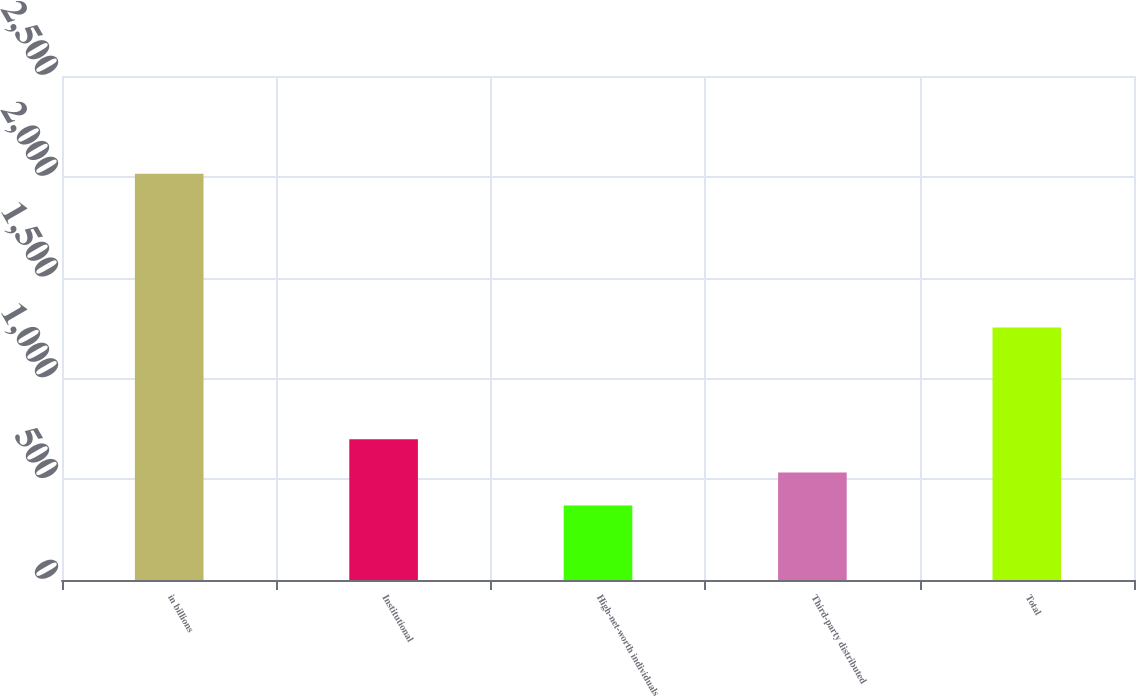Convert chart to OTSL. <chart><loc_0><loc_0><loc_500><loc_500><bar_chart><fcel>in billions<fcel>Institutional<fcel>High-net-worth individuals<fcel>Third-party distributed<fcel>Total<nl><fcel>2015<fcel>698.2<fcel>369<fcel>533.6<fcel>1252<nl></chart> 